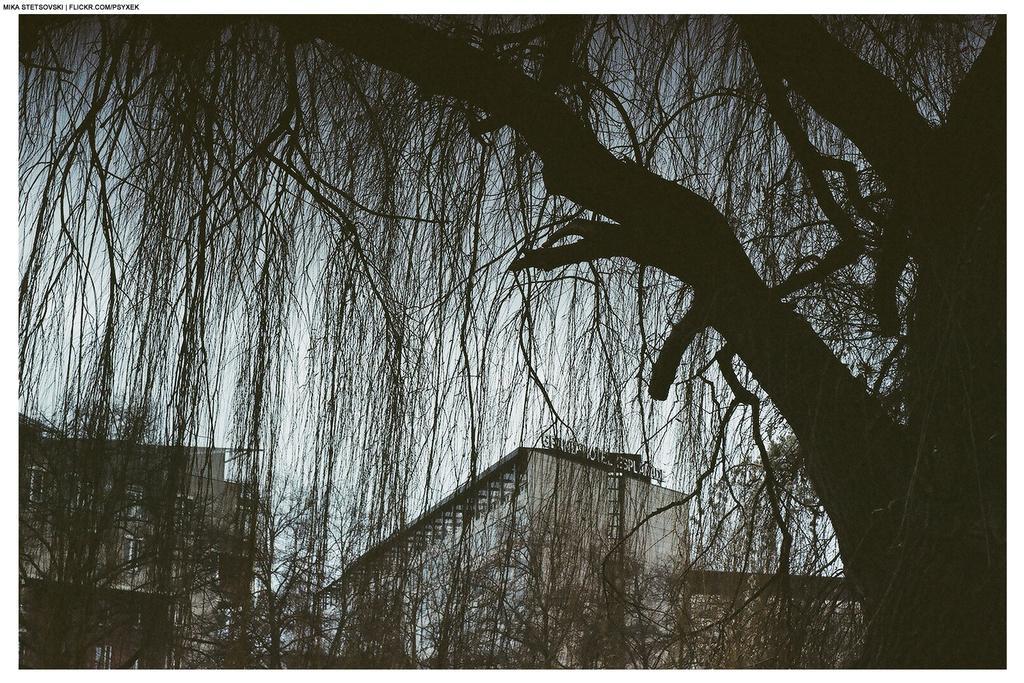Can you describe this image briefly? In this picture we can see buildings, trees and we can see sky in the background. 